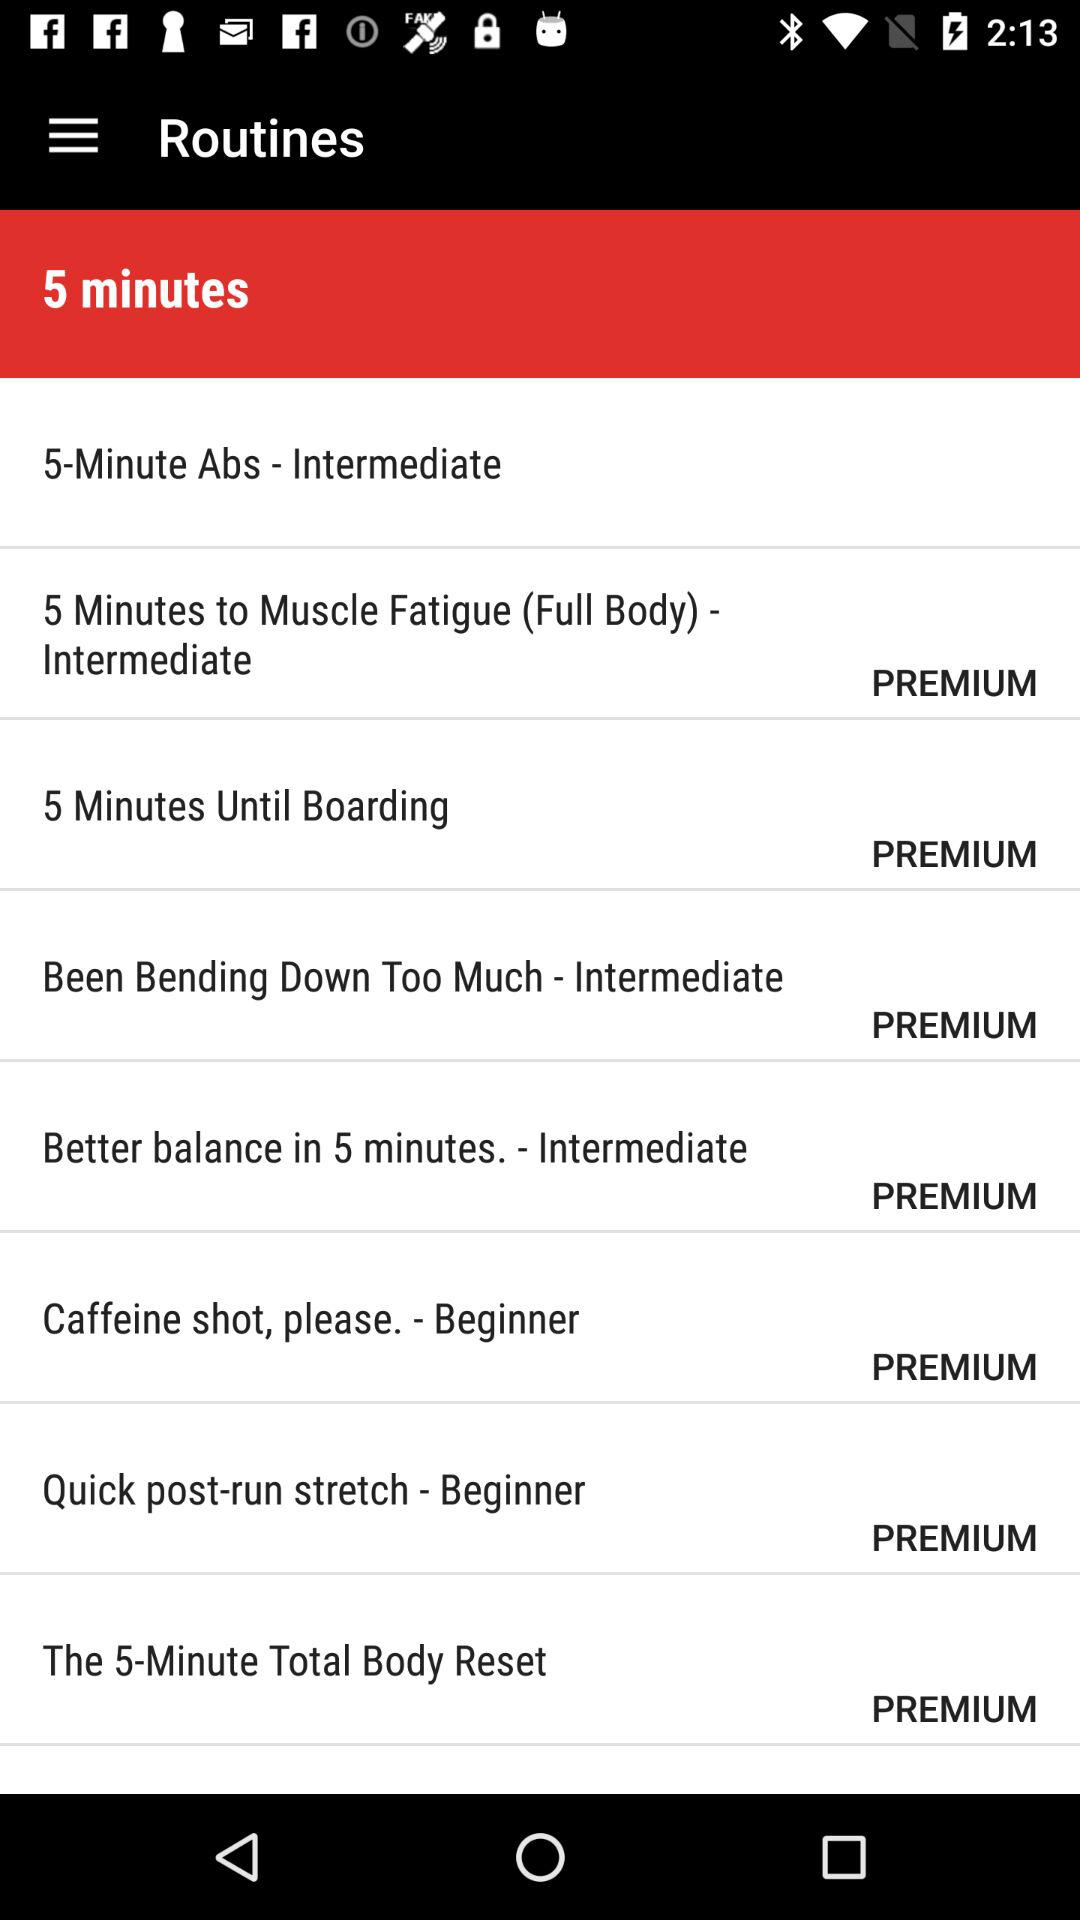What is the duration of "Caffeine shot, please."?
When the provided information is insufficient, respond with <no answer>. <no answer> 